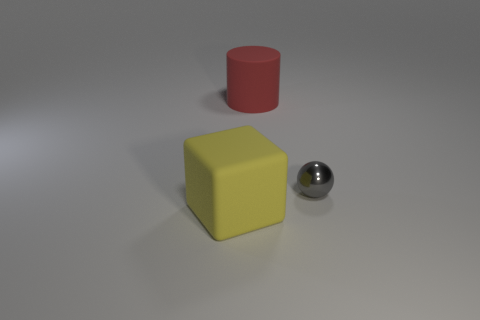Add 2 tiny green cubes. How many objects exist? 5 Subtract all cylinders. How many objects are left? 2 Add 1 matte cylinders. How many matte cylinders are left? 2 Add 3 tiny shiny spheres. How many tiny shiny spheres exist? 4 Subtract 0 yellow cylinders. How many objects are left? 3 Subtract all red objects. Subtract all red matte things. How many objects are left? 1 